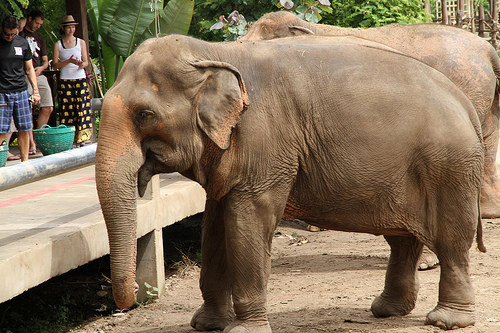The girl near the elephant is wearing what? The girl near the elephant is wearing a skirt. 